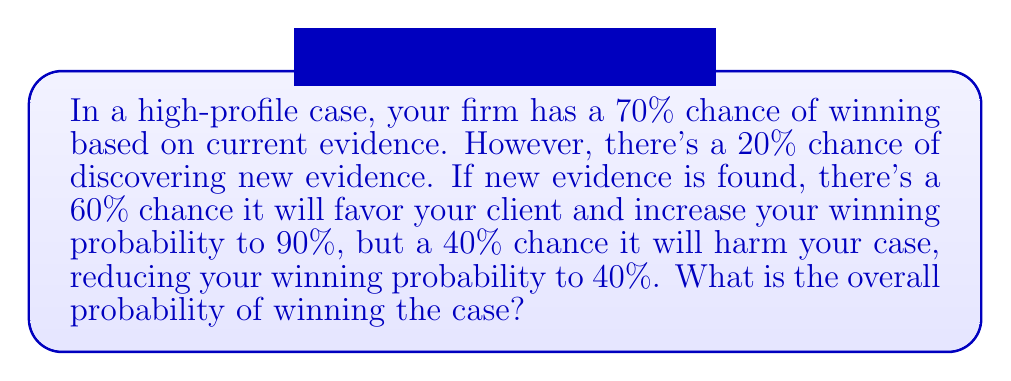What is the answer to this math problem? Let's approach this step-by-step:

1) Define events:
   W: Winning the case
   N: New evidence is discovered
   F: New evidence favors your client
   H: New evidence harms your case

2) Given probabilities:
   P(W|no new evidence) = 0.70
   P(N) = 0.20
   P(F|N) = 0.60
   P(H|N) = 0.40
   P(W|N,F) = 0.90
   P(W|N,H) = 0.40

3) Use the law of total probability:
   P(W) = P(W|no new evidence) * P(no new evidence) + P(W|N,F) * P(N) * P(F|N) + P(W|N,H) * P(N) * P(H|N)

4) Substitute the values:
   P(W) = 0.70 * 0.80 + 0.90 * 0.20 * 0.60 + 0.40 * 0.20 * 0.40

5) Calculate:
   P(W) = 0.56 + 0.108 + 0.032 = 0.70

6) Convert to percentage:
   0.70 * 100 = 70%

Therefore, the overall probability of winning the case is 70%.
Answer: 70% 